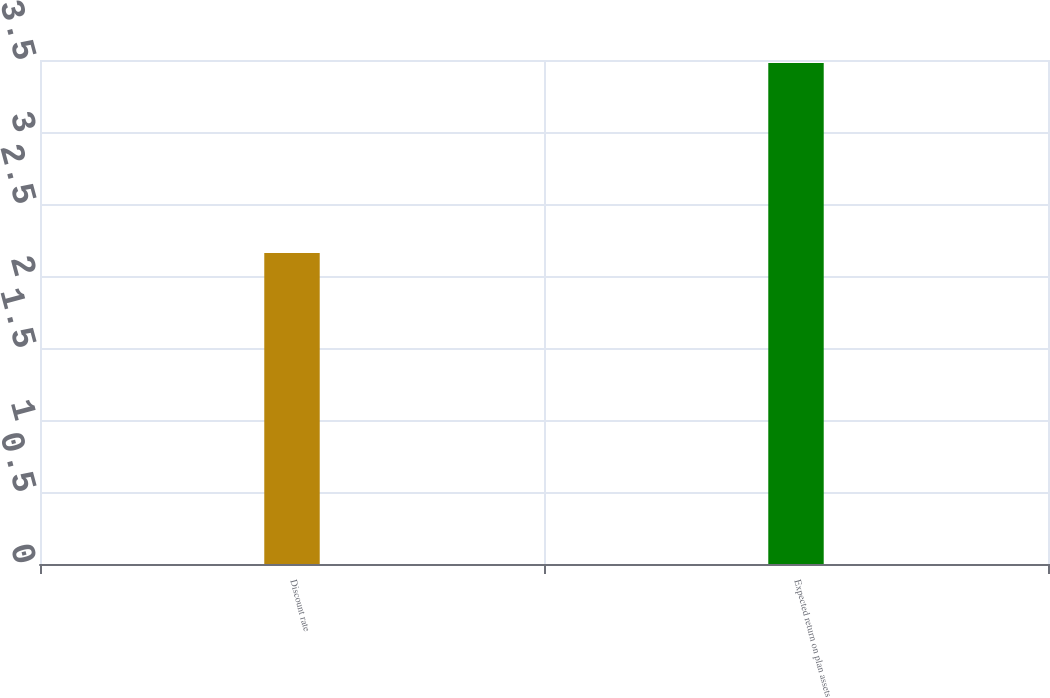Convert chart to OTSL. <chart><loc_0><loc_0><loc_500><loc_500><bar_chart><fcel>Discount rate<fcel>Expected return on plan assets<nl><fcel>2.16<fcel>3.48<nl></chart> 